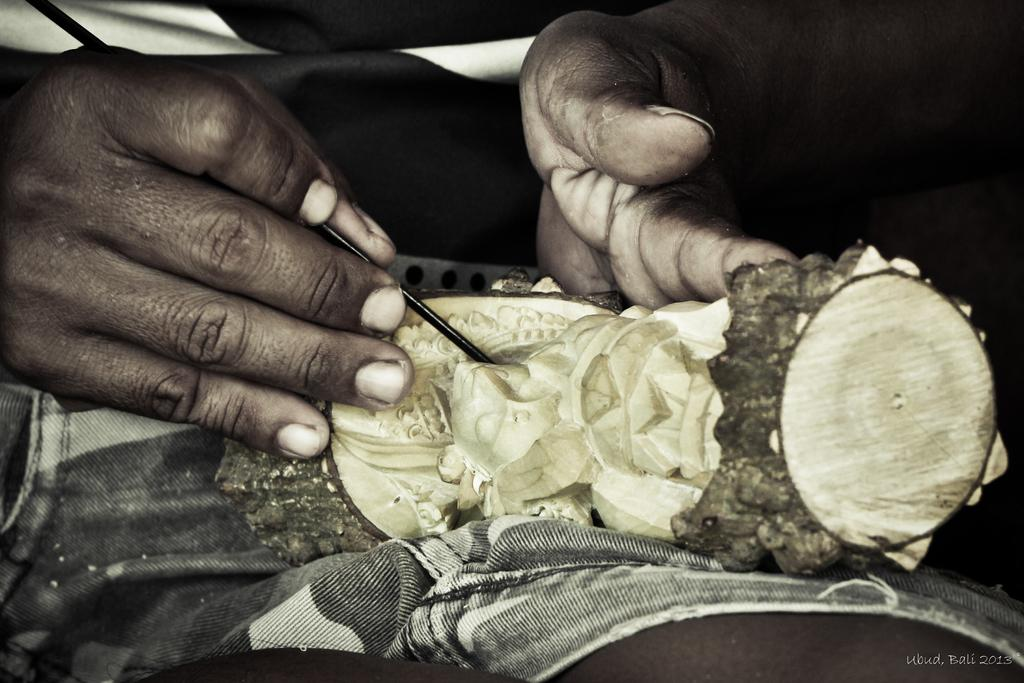What is the main subject of the image? There is a person in the center of the image. What activity is the person engaged in? The person is doing some art. What object is the person holding while doing the art? The person is holding a wooden stick. What type of patch is the person wearing on their clothing in the image? There is no patch visible on the person's clothing in the image. 